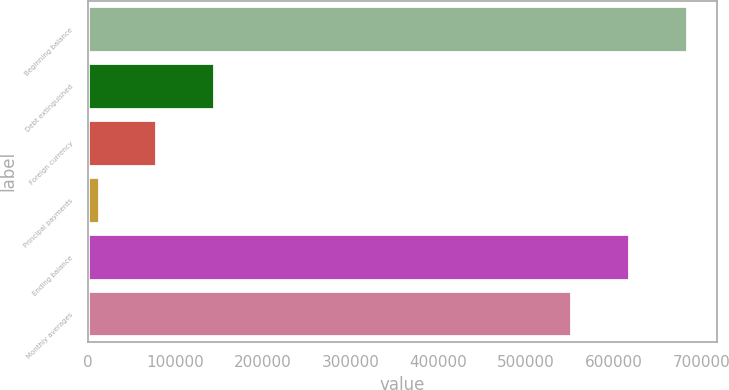Convert chart to OTSL. <chart><loc_0><loc_0><loc_500><loc_500><bar_chart><fcel>Beginning balance<fcel>Debt extinguished<fcel>Foreign currency<fcel>Principal payments<fcel>Ending balance<fcel>Monthly averages<nl><fcel>683413<fcel>144329<fcel>78524<fcel>12719<fcel>617608<fcel>551803<nl></chart> 